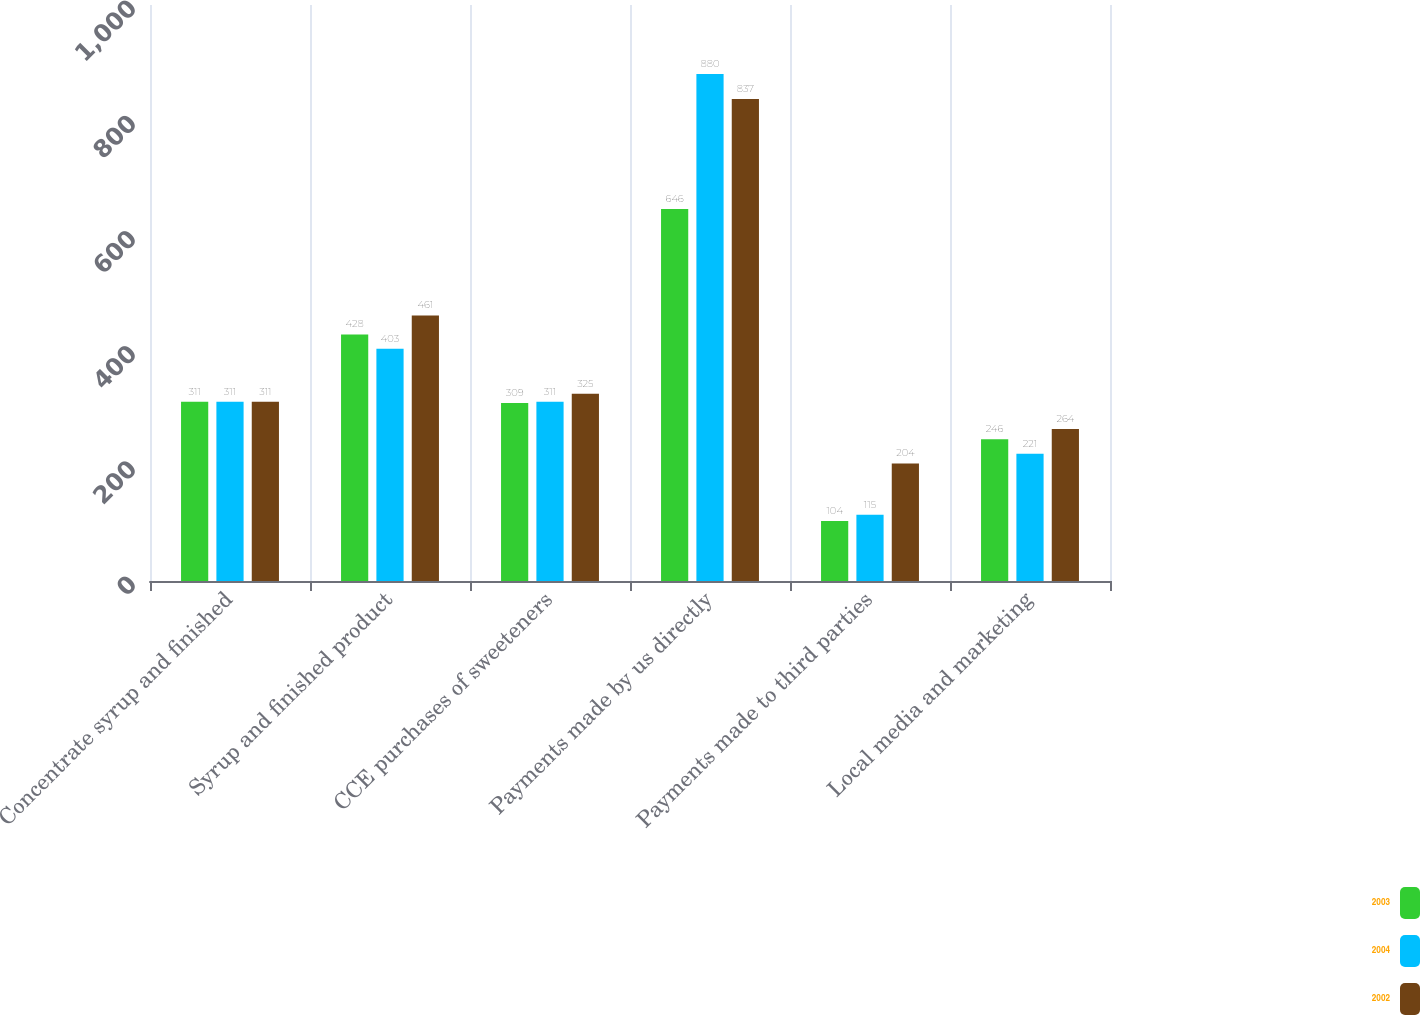Convert chart to OTSL. <chart><loc_0><loc_0><loc_500><loc_500><stacked_bar_chart><ecel><fcel>Concentrate syrup and finished<fcel>Syrup and finished product<fcel>CCE purchases of sweeteners<fcel>Payments made by us directly<fcel>Payments made to third parties<fcel>Local media and marketing<nl><fcel>2003<fcel>311<fcel>428<fcel>309<fcel>646<fcel>104<fcel>246<nl><fcel>2004<fcel>311<fcel>403<fcel>311<fcel>880<fcel>115<fcel>221<nl><fcel>2002<fcel>311<fcel>461<fcel>325<fcel>837<fcel>204<fcel>264<nl></chart> 